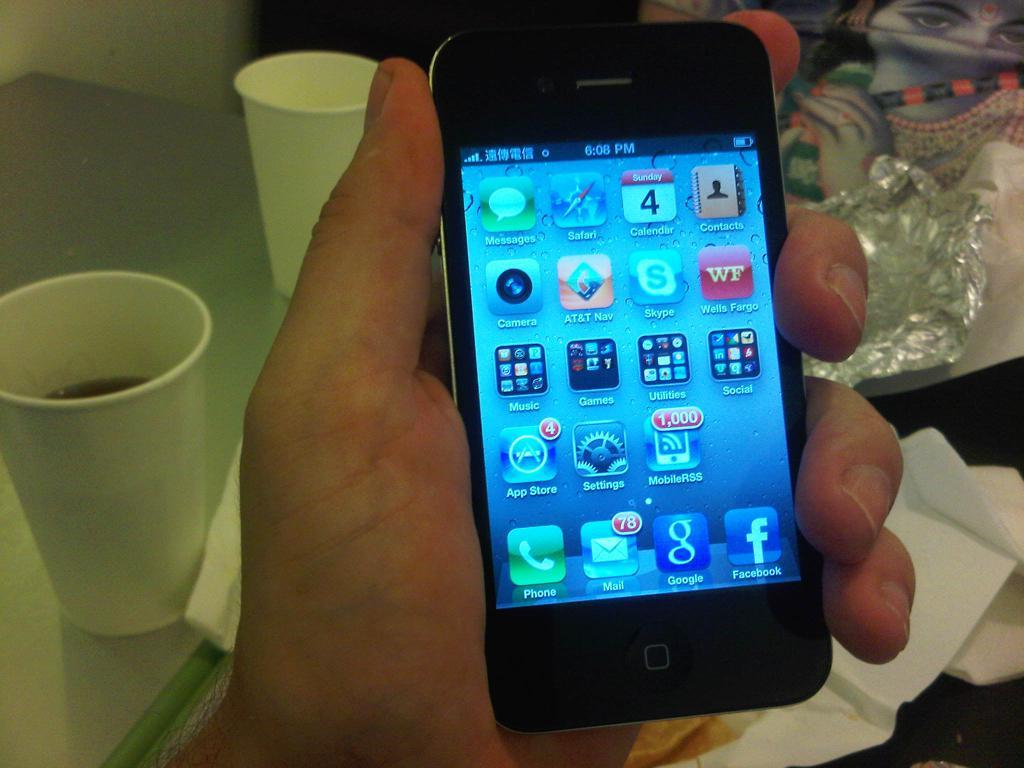<image>
Create a compact narrative representing the image presented. A hand holds a smartphone with a bunch of different icons on it 